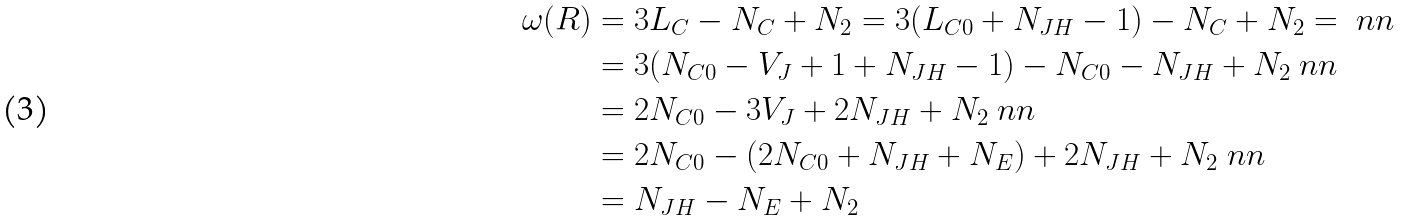<formula> <loc_0><loc_0><loc_500><loc_500>\omega ( R ) & = 3 L _ { C } - N _ { C } + N _ { 2 } = 3 ( L _ { C 0 } + N _ { J H } - 1 ) - N _ { C } + N _ { 2 } = \ n n \\ & = 3 ( N _ { C 0 } - V _ { J } + 1 + N _ { J H } - 1 ) - N _ { C 0 } - N _ { J H } + N _ { 2 } \ n n \\ & = 2 N _ { C 0 } - 3 V _ { J } + 2 N _ { J H } + N _ { 2 } \ n n \\ & = 2 N _ { C 0 } - ( 2 N _ { C 0 } + N _ { J H } + N _ { E } ) + 2 N _ { J H } + N _ { 2 } \ n n \\ & = N _ { J H } - N _ { E } + N _ { 2 }</formula> 